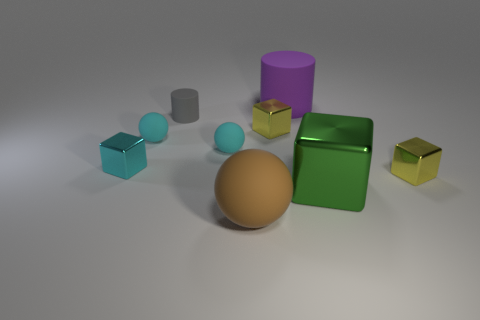There is a metal block that is the same size as the purple cylinder; what is its color?
Make the answer very short. Green. Are there any small metal blocks that have the same color as the big metal cube?
Ensure brevity in your answer.  No. What number of objects are either yellow metallic things on the right side of the large block or big matte things?
Keep it short and to the point. 3. What number of other objects are the same size as the green block?
Make the answer very short. 2. There is a large brown sphere in front of the yellow block that is in front of the tiny yellow object behind the cyan cube; what is it made of?
Your response must be concise. Rubber. What number of cylinders are small yellow things or green things?
Offer a very short reply. 0. Is there anything else that has the same shape as the green thing?
Keep it short and to the point. Yes. Are there more cyan matte objects that are in front of the large cube than small objects on the right side of the big matte cylinder?
Ensure brevity in your answer.  No. There is a shiny object left of the brown object; how many rubber things are behind it?
Make the answer very short. 4. How many things are either small rubber cylinders or large purple things?
Make the answer very short. 2. 